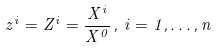Convert formula to latex. <formula><loc_0><loc_0><loc_500><loc_500>z ^ { i } = Z ^ { i } = \frac { X ^ { i } } { X ^ { 0 } } \, , \, i = 1 , \dots , n \,</formula> 